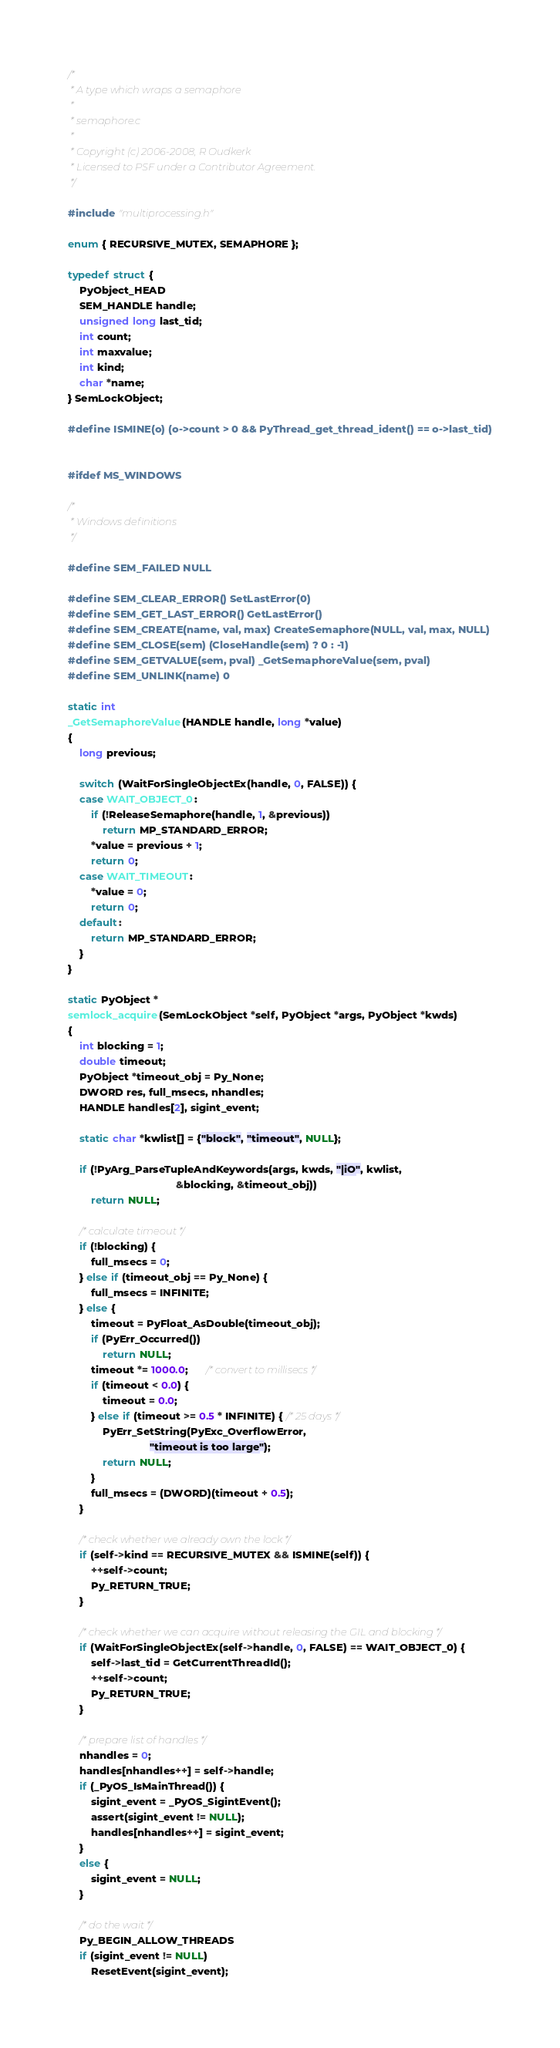<code> <loc_0><loc_0><loc_500><loc_500><_C_>/*
 * A type which wraps a semaphore
 *
 * semaphore.c
 *
 * Copyright (c) 2006-2008, R Oudkerk
 * Licensed to PSF under a Contributor Agreement.
 */

#include "multiprocessing.h"

enum { RECURSIVE_MUTEX, SEMAPHORE };

typedef struct {
    PyObject_HEAD
    SEM_HANDLE handle;
    unsigned long last_tid;
    int count;
    int maxvalue;
    int kind;
    char *name;
} SemLockObject;

#define ISMINE(o) (o->count > 0 && PyThread_get_thread_ident() == o->last_tid)


#ifdef MS_WINDOWS

/*
 * Windows definitions
 */

#define SEM_FAILED NULL

#define SEM_CLEAR_ERROR() SetLastError(0)
#define SEM_GET_LAST_ERROR() GetLastError()
#define SEM_CREATE(name, val, max) CreateSemaphore(NULL, val, max, NULL)
#define SEM_CLOSE(sem) (CloseHandle(sem) ? 0 : -1)
#define SEM_GETVALUE(sem, pval) _GetSemaphoreValue(sem, pval)
#define SEM_UNLINK(name) 0

static int
_GetSemaphoreValue(HANDLE handle, long *value)
{
    long previous;

    switch (WaitForSingleObjectEx(handle, 0, FALSE)) {
    case WAIT_OBJECT_0:
        if (!ReleaseSemaphore(handle, 1, &previous))
            return MP_STANDARD_ERROR;
        *value = previous + 1;
        return 0;
    case WAIT_TIMEOUT:
        *value = 0;
        return 0;
    default:
        return MP_STANDARD_ERROR;
    }
}

static PyObject *
semlock_acquire(SemLockObject *self, PyObject *args, PyObject *kwds)
{
    int blocking = 1;
    double timeout;
    PyObject *timeout_obj = Py_None;
    DWORD res, full_msecs, nhandles;
    HANDLE handles[2], sigint_event;

    static char *kwlist[] = {"block", "timeout", NULL};

    if (!PyArg_ParseTupleAndKeywords(args, kwds, "|iO", kwlist,
                                     &blocking, &timeout_obj))
        return NULL;

    /* calculate timeout */
    if (!blocking) {
        full_msecs = 0;
    } else if (timeout_obj == Py_None) {
        full_msecs = INFINITE;
    } else {
        timeout = PyFloat_AsDouble(timeout_obj);
        if (PyErr_Occurred())
            return NULL;
        timeout *= 1000.0;      /* convert to millisecs */
        if (timeout < 0.0) {
            timeout = 0.0;
        } else if (timeout >= 0.5 * INFINITE) { /* 25 days */
            PyErr_SetString(PyExc_OverflowError,
                            "timeout is too large");
            return NULL;
        }
        full_msecs = (DWORD)(timeout + 0.5);
    }

    /* check whether we already own the lock */
    if (self->kind == RECURSIVE_MUTEX && ISMINE(self)) {
        ++self->count;
        Py_RETURN_TRUE;
    }

    /* check whether we can acquire without releasing the GIL and blocking */
    if (WaitForSingleObjectEx(self->handle, 0, FALSE) == WAIT_OBJECT_0) {
        self->last_tid = GetCurrentThreadId();
        ++self->count;
        Py_RETURN_TRUE;
    }

    /* prepare list of handles */
    nhandles = 0;
    handles[nhandles++] = self->handle;
    if (_PyOS_IsMainThread()) {
        sigint_event = _PyOS_SigintEvent();
        assert(sigint_event != NULL);
        handles[nhandles++] = sigint_event;
    }
    else {
        sigint_event = NULL;
    }

    /* do the wait */
    Py_BEGIN_ALLOW_THREADS
    if (sigint_event != NULL)
        ResetEvent(sigint_event);</code> 